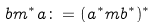<formula> <loc_0><loc_0><loc_500><loc_500>b m ^ { * } a \colon = ( a ^ { * } m b ^ { * } ) ^ { * }</formula> 